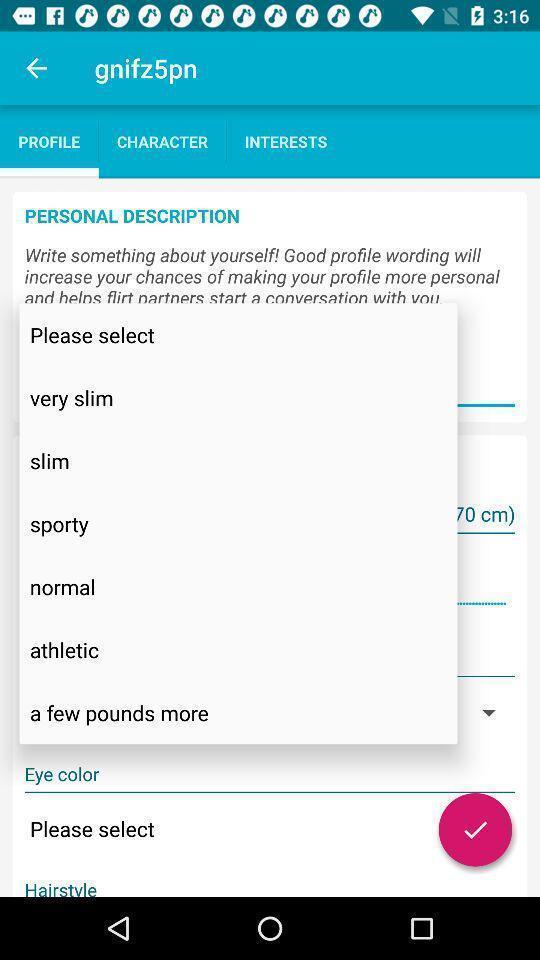Give me a summary of this screen capture. Popup to select body type. 